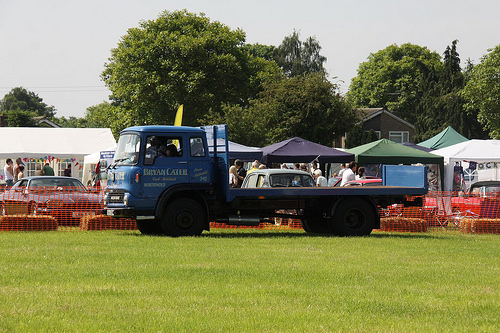<image>
Can you confirm if the truck is behind the fence? No. The truck is not behind the fence. From this viewpoint, the truck appears to be positioned elsewhere in the scene. Is the car in front of the truck? No. The car is not in front of the truck. The spatial positioning shows a different relationship between these objects. 